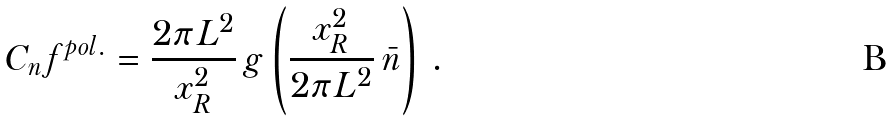<formula> <loc_0><loc_0><loc_500><loc_500>C _ { n } f ^ { p o l . } = \frac { 2 \pi L ^ { 2 } } { x _ { R } ^ { 2 } } \, g \left ( \frac { x _ { R } ^ { 2 } } { 2 \pi L ^ { 2 } } \, \bar { n } \right ) \, .</formula> 